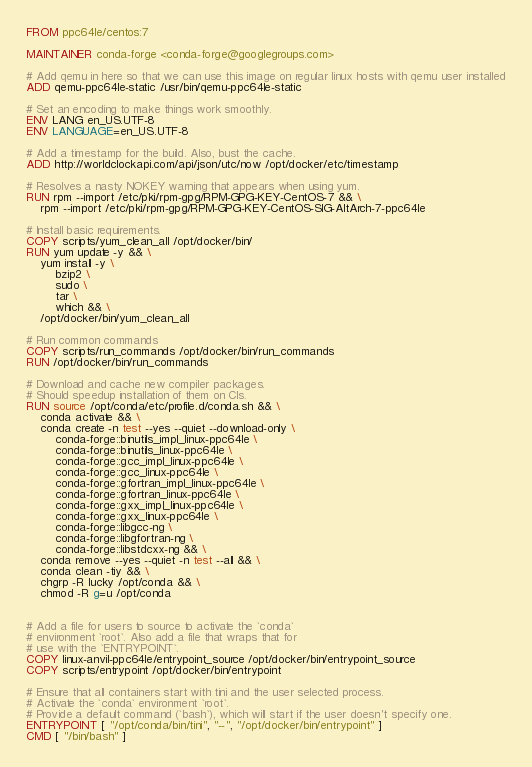<code> <loc_0><loc_0><loc_500><loc_500><_Dockerfile_>FROM ppc64le/centos:7

MAINTAINER conda-forge <conda-forge@googlegroups.com>

# Add qemu in here so that we can use this image on regular linux hosts with qemu user installed
ADD qemu-ppc64le-static /usr/bin/qemu-ppc64le-static

# Set an encoding to make things work smoothly.
ENV LANG en_US.UTF-8
ENV LANGUAGE=en_US.UTF-8

# Add a timestamp for the build. Also, bust the cache.
ADD http://worldclockapi.com/api/json/utc/now /opt/docker/etc/timestamp

# Resolves a nasty NOKEY warning that appears when using yum.
RUN rpm --import /etc/pki/rpm-gpg/RPM-GPG-KEY-CentOS-7 && \
    rpm --import /etc/pki/rpm-gpg/RPM-GPG-KEY-CentOS-SIG-AltArch-7-ppc64le

# Install basic requirements.
COPY scripts/yum_clean_all /opt/docker/bin/
RUN yum update -y && \
    yum install -y \
        bzip2 \
        sudo \
        tar \
        which && \
    /opt/docker/bin/yum_clean_all

# Run common commands
COPY scripts/run_commands /opt/docker/bin/run_commands
RUN /opt/docker/bin/run_commands

# Download and cache new compiler packages.
# Should speedup installation of them on CIs.
RUN source /opt/conda/etc/profile.d/conda.sh && \
    conda activate && \
    conda create -n test --yes --quiet --download-only \
        conda-forge::binutils_impl_linux-ppc64le \
        conda-forge::binutils_linux-ppc64le \
        conda-forge::gcc_impl_linux-ppc64le \
        conda-forge::gcc_linux-ppc64le \
        conda-forge::gfortran_impl_linux-ppc64le \
        conda-forge::gfortran_linux-ppc64le \
        conda-forge::gxx_impl_linux-ppc64le \
        conda-forge::gxx_linux-ppc64le \
        conda-forge::libgcc-ng \
        conda-forge::libgfortran-ng \
        conda-forge::libstdcxx-ng && \
    conda remove --yes --quiet -n test --all && \
    conda clean -tiy && \
    chgrp -R lucky /opt/conda && \
    chmod -R g=u /opt/conda


# Add a file for users to source to activate the `conda`
# environment `root`. Also add a file that wraps that for
# use with the `ENTRYPOINT`.
COPY linux-anvil-ppc64le/entrypoint_source /opt/docker/bin/entrypoint_source
COPY scripts/entrypoint /opt/docker/bin/entrypoint

# Ensure that all containers start with tini and the user selected process.
# Activate the `conda` environment `root`.
# Provide a default command (`bash`), which will start if the user doesn't specify one.
ENTRYPOINT [ "/opt/conda/bin/tini", "--", "/opt/docker/bin/entrypoint" ]
CMD [ "/bin/bash" ]
</code> 